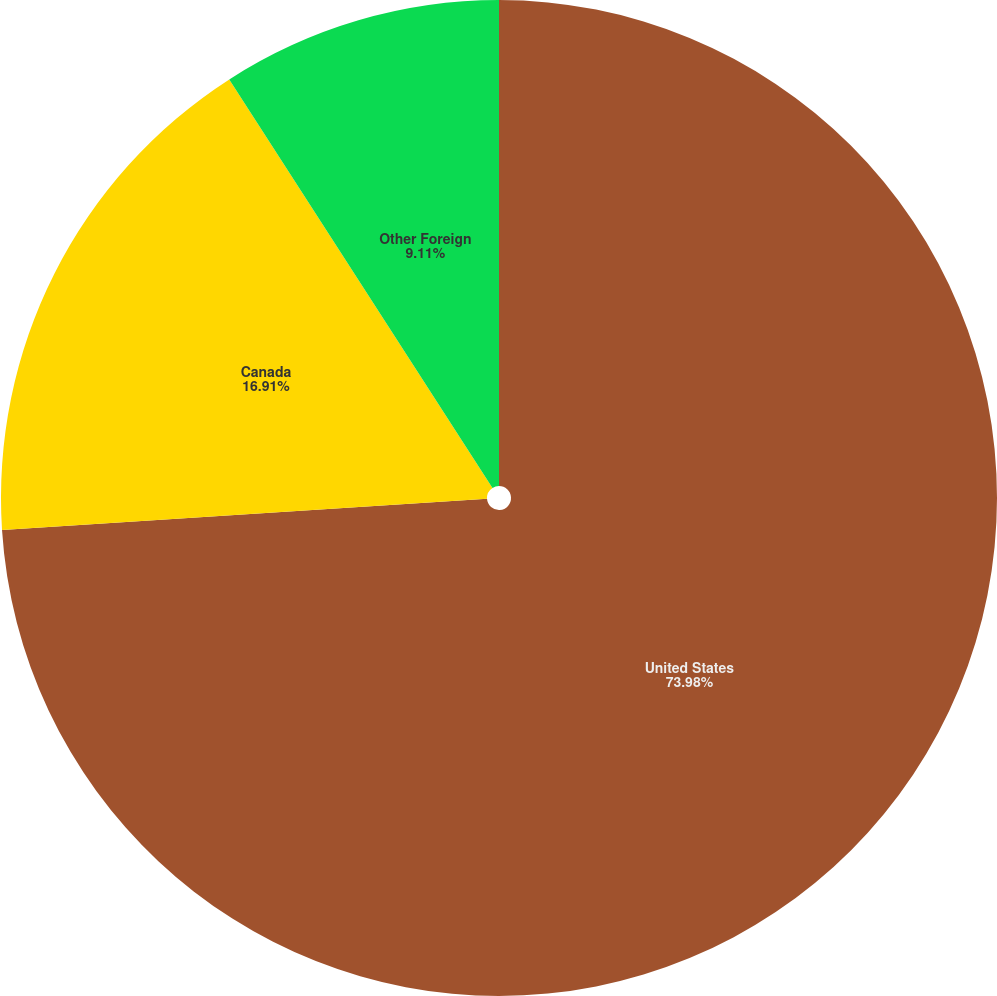Convert chart to OTSL. <chart><loc_0><loc_0><loc_500><loc_500><pie_chart><fcel>United States<fcel>Canada<fcel>Other Foreign<nl><fcel>73.98%<fcel>16.91%<fcel>9.11%<nl></chart> 